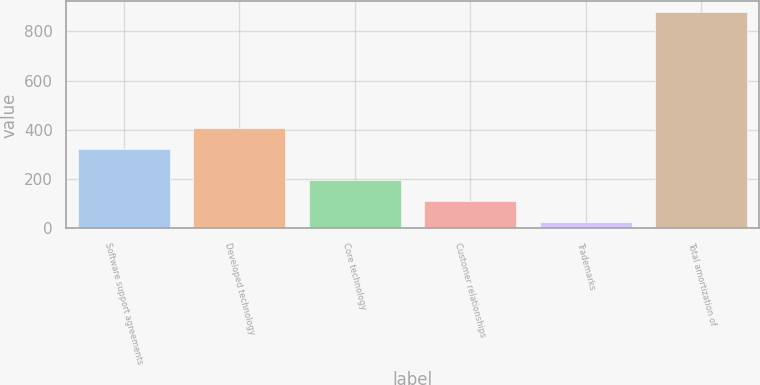Convert chart. <chart><loc_0><loc_0><loc_500><loc_500><bar_chart><fcel>Software support agreements<fcel>Developed technology<fcel>Core technology<fcel>Customer relationships<fcel>Trademarks<fcel>Total amortization of<nl><fcel>321<fcel>406.3<fcel>195.6<fcel>110.3<fcel>25<fcel>878<nl></chart> 